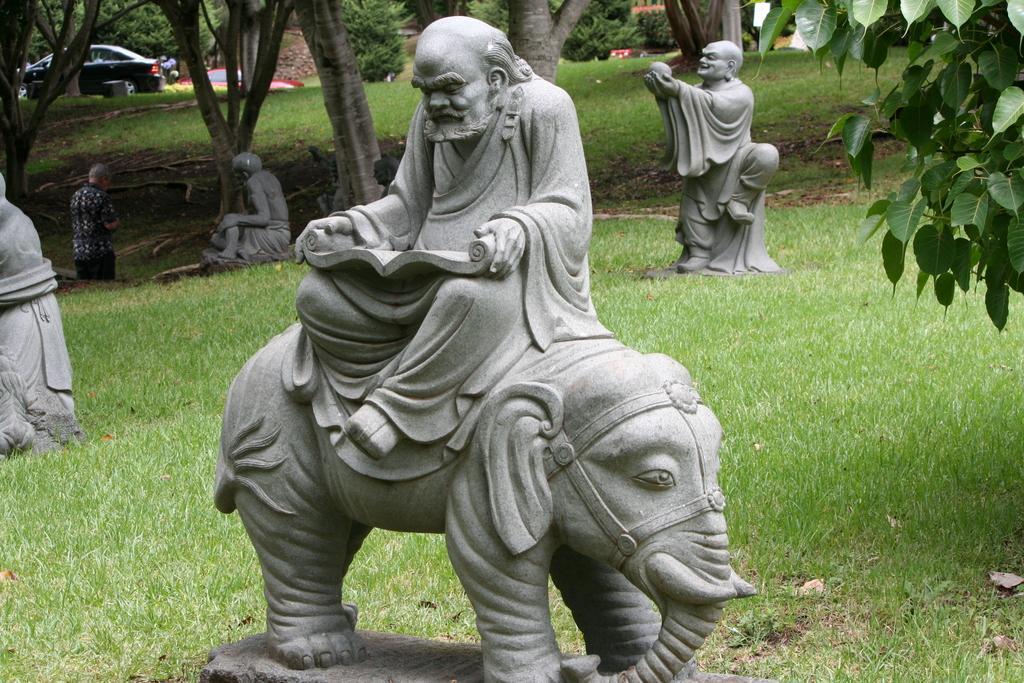Could you give a brief overview of what you see in this image? In this image I can see few statues of few people and an animal. In the background I can see few vehicles, trees and I can also see the person standing. 